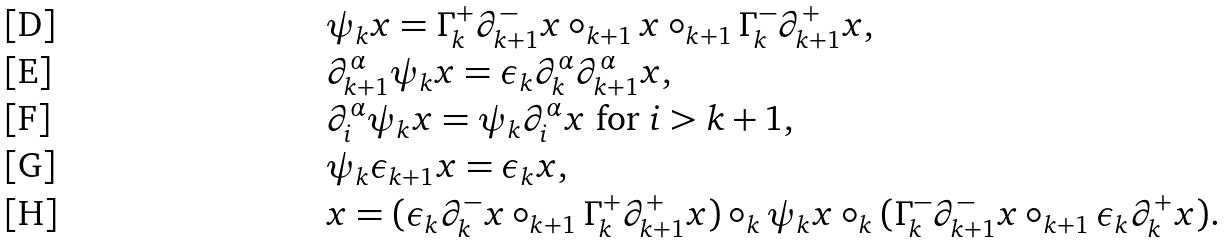<formula> <loc_0><loc_0><loc_500><loc_500>& \psi _ { k } x = \Gamma _ { k } ^ { + } \partial _ { k + 1 } ^ { - } x \circ _ { k + 1 } x \circ _ { k + 1 } \Gamma _ { k } ^ { - } \partial _ { k + 1 } ^ { + } x , \\ & \partial _ { k + 1 } ^ { \alpha } \psi _ { k } x = \epsilon _ { k } \partial _ { k } ^ { \alpha } \partial _ { k + 1 } ^ { \alpha } x , \\ & \partial _ { i } ^ { \alpha } \psi _ { k } x = \psi _ { k } \partial _ { i } ^ { \alpha } x \ \text {for $i>k+1$} , \\ & \psi _ { k } \epsilon _ { k + 1 } x = \epsilon _ { k } x , \\ & x = ( \epsilon _ { k } \partial _ { k } ^ { - } x \circ _ { k + 1 } \Gamma _ { k } ^ { + } \partial _ { k + 1 } ^ { + } x ) \circ _ { k } \psi _ { k } x \circ _ { k } ( \Gamma _ { k } ^ { - } \partial _ { k + 1 } ^ { - } x \circ _ { k + 1 } \epsilon _ { k } \partial _ { k } ^ { + } x ) .</formula> 